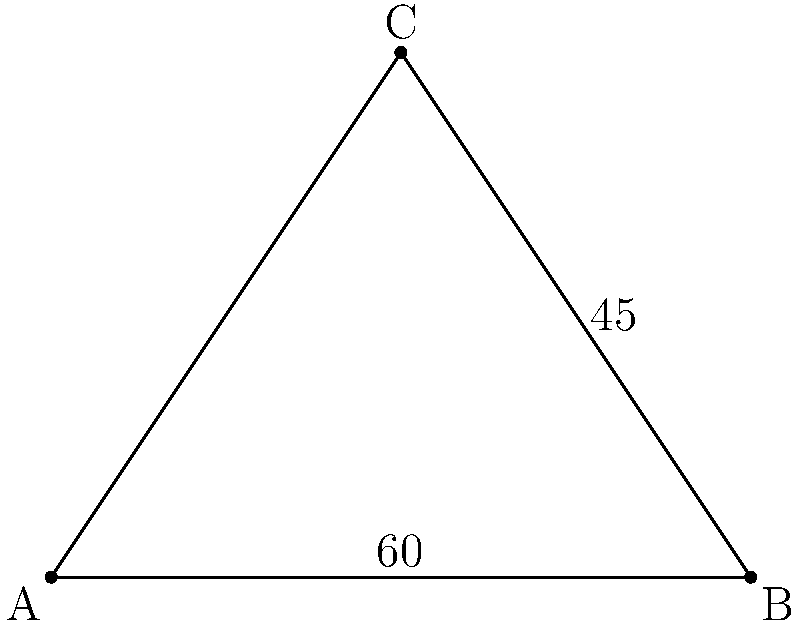In a classical Indian dance pose, a dancer forms a triangle with her arms and torso. The angle between her right arm and torso is 60°, and the angle between her left arm and torso is 45°. What is the angle formed between her arms? Let's approach this step-by-step:

1) In a triangle, the sum of all interior angles is always 180°.

2) Let's call the angle between the arms $x°$.

3) We can set up an equation based on the fact that all angles in a triangle sum to 180°:

   $60° + 45° + x° = 180°$

4) Simplify the left side of the equation:

   $105° + x° = 180°$

5) Subtract 105° from both sides:

   $x° = 180° - 105°$

6) Simplify:

   $x° = 75°$

Therefore, the angle formed between the dancer's arms is 75°.
Answer: 75° 